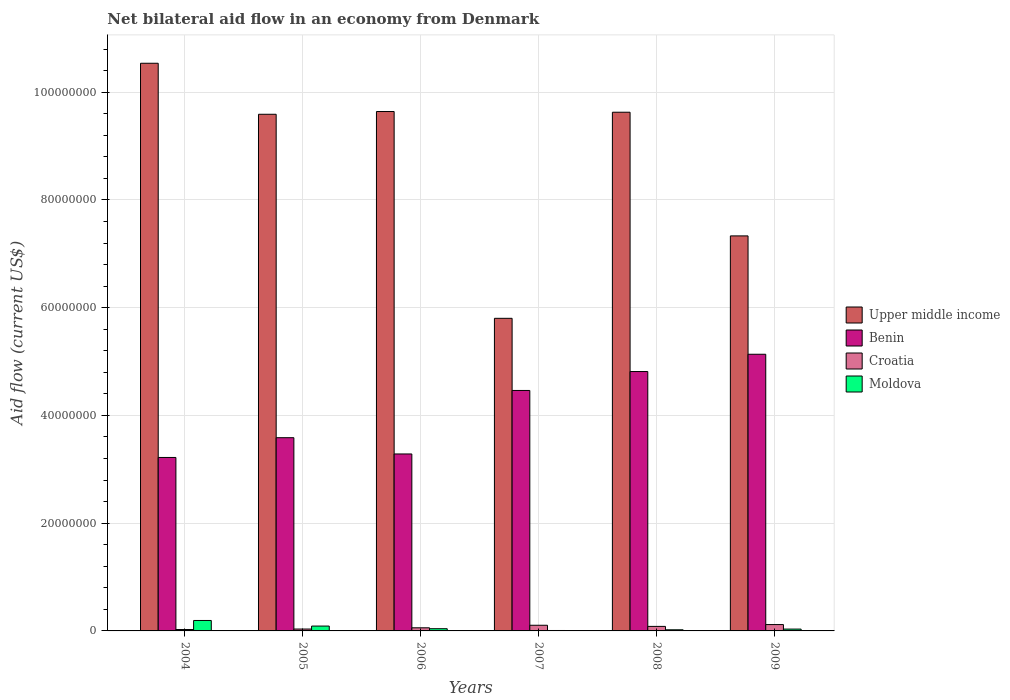How many different coloured bars are there?
Keep it short and to the point. 4. How many groups of bars are there?
Your answer should be compact. 6. How many bars are there on the 1st tick from the right?
Make the answer very short. 4. What is the label of the 2nd group of bars from the left?
Your answer should be very brief. 2005. What is the net bilateral aid flow in Upper middle income in 2009?
Provide a succinct answer. 7.33e+07. Across all years, what is the maximum net bilateral aid flow in Benin?
Offer a terse response. 5.14e+07. Across all years, what is the minimum net bilateral aid flow in Moldova?
Make the answer very short. 8.00e+04. In which year was the net bilateral aid flow in Croatia maximum?
Make the answer very short. 2009. What is the total net bilateral aid flow in Benin in the graph?
Ensure brevity in your answer.  2.45e+08. What is the difference between the net bilateral aid flow in Upper middle income in 2004 and that in 2007?
Your response must be concise. 4.74e+07. What is the difference between the net bilateral aid flow in Upper middle income in 2008 and the net bilateral aid flow in Benin in 2009?
Give a very brief answer. 4.49e+07. What is the average net bilateral aid flow in Upper middle income per year?
Make the answer very short. 8.76e+07. In the year 2008, what is the difference between the net bilateral aid flow in Croatia and net bilateral aid flow in Benin?
Offer a terse response. -4.73e+07. What is the ratio of the net bilateral aid flow in Upper middle income in 2005 to that in 2006?
Your answer should be compact. 0.99. Is the net bilateral aid flow in Croatia in 2005 less than that in 2006?
Provide a succinct answer. Yes. Is the difference between the net bilateral aid flow in Croatia in 2007 and 2008 greater than the difference between the net bilateral aid flow in Benin in 2007 and 2008?
Give a very brief answer. Yes. What is the difference between the highest and the second highest net bilateral aid flow in Moldova?
Your response must be concise. 1.04e+06. What is the difference between the highest and the lowest net bilateral aid flow in Upper middle income?
Provide a succinct answer. 4.74e+07. Is the sum of the net bilateral aid flow in Upper middle income in 2006 and 2007 greater than the maximum net bilateral aid flow in Croatia across all years?
Your answer should be very brief. Yes. Is it the case that in every year, the sum of the net bilateral aid flow in Upper middle income and net bilateral aid flow in Benin is greater than the sum of net bilateral aid flow in Croatia and net bilateral aid flow in Moldova?
Make the answer very short. Yes. What does the 3rd bar from the left in 2005 represents?
Give a very brief answer. Croatia. What does the 3rd bar from the right in 2007 represents?
Your answer should be very brief. Benin. Is it the case that in every year, the sum of the net bilateral aid flow in Croatia and net bilateral aid flow in Benin is greater than the net bilateral aid flow in Upper middle income?
Ensure brevity in your answer.  No. How many bars are there?
Ensure brevity in your answer.  24. What is the difference between two consecutive major ticks on the Y-axis?
Make the answer very short. 2.00e+07. Are the values on the major ticks of Y-axis written in scientific E-notation?
Keep it short and to the point. No. Does the graph contain any zero values?
Offer a very short reply. No. Does the graph contain grids?
Provide a short and direct response. Yes. Where does the legend appear in the graph?
Offer a very short reply. Center right. How many legend labels are there?
Your answer should be very brief. 4. How are the legend labels stacked?
Your response must be concise. Vertical. What is the title of the graph?
Your response must be concise. Net bilateral aid flow in an economy from Denmark. What is the label or title of the X-axis?
Offer a very short reply. Years. What is the label or title of the Y-axis?
Keep it short and to the point. Aid flow (current US$). What is the Aid flow (current US$) of Upper middle income in 2004?
Offer a very short reply. 1.05e+08. What is the Aid flow (current US$) of Benin in 2004?
Provide a short and direct response. 3.22e+07. What is the Aid flow (current US$) of Croatia in 2004?
Provide a short and direct response. 2.60e+05. What is the Aid flow (current US$) of Moldova in 2004?
Your answer should be compact. 1.94e+06. What is the Aid flow (current US$) of Upper middle income in 2005?
Your answer should be very brief. 9.59e+07. What is the Aid flow (current US$) in Benin in 2005?
Provide a succinct answer. 3.59e+07. What is the Aid flow (current US$) in Upper middle income in 2006?
Ensure brevity in your answer.  9.64e+07. What is the Aid flow (current US$) in Benin in 2006?
Offer a very short reply. 3.28e+07. What is the Aid flow (current US$) in Croatia in 2006?
Offer a very short reply. 5.80e+05. What is the Aid flow (current US$) of Moldova in 2006?
Give a very brief answer. 4.10e+05. What is the Aid flow (current US$) in Upper middle income in 2007?
Provide a succinct answer. 5.80e+07. What is the Aid flow (current US$) of Benin in 2007?
Ensure brevity in your answer.  4.46e+07. What is the Aid flow (current US$) in Croatia in 2007?
Give a very brief answer. 1.05e+06. What is the Aid flow (current US$) in Moldova in 2007?
Offer a very short reply. 8.00e+04. What is the Aid flow (current US$) in Upper middle income in 2008?
Your response must be concise. 9.63e+07. What is the Aid flow (current US$) in Benin in 2008?
Your answer should be compact. 4.82e+07. What is the Aid flow (current US$) in Croatia in 2008?
Provide a short and direct response. 8.40e+05. What is the Aid flow (current US$) in Moldova in 2008?
Keep it short and to the point. 2.10e+05. What is the Aid flow (current US$) in Upper middle income in 2009?
Offer a terse response. 7.33e+07. What is the Aid flow (current US$) in Benin in 2009?
Keep it short and to the point. 5.14e+07. What is the Aid flow (current US$) in Croatia in 2009?
Offer a very short reply. 1.18e+06. What is the Aid flow (current US$) in Moldova in 2009?
Give a very brief answer. 3.40e+05. Across all years, what is the maximum Aid flow (current US$) in Upper middle income?
Give a very brief answer. 1.05e+08. Across all years, what is the maximum Aid flow (current US$) of Benin?
Ensure brevity in your answer.  5.14e+07. Across all years, what is the maximum Aid flow (current US$) in Croatia?
Provide a short and direct response. 1.18e+06. Across all years, what is the maximum Aid flow (current US$) of Moldova?
Give a very brief answer. 1.94e+06. Across all years, what is the minimum Aid flow (current US$) of Upper middle income?
Your response must be concise. 5.80e+07. Across all years, what is the minimum Aid flow (current US$) of Benin?
Your response must be concise. 3.22e+07. Across all years, what is the minimum Aid flow (current US$) of Croatia?
Offer a very short reply. 2.60e+05. What is the total Aid flow (current US$) of Upper middle income in the graph?
Ensure brevity in your answer.  5.25e+08. What is the total Aid flow (current US$) in Benin in the graph?
Offer a very short reply. 2.45e+08. What is the total Aid flow (current US$) in Croatia in the graph?
Keep it short and to the point. 4.26e+06. What is the total Aid flow (current US$) of Moldova in the graph?
Make the answer very short. 3.88e+06. What is the difference between the Aid flow (current US$) in Upper middle income in 2004 and that in 2005?
Give a very brief answer. 9.47e+06. What is the difference between the Aid flow (current US$) in Benin in 2004 and that in 2005?
Provide a succinct answer. -3.67e+06. What is the difference between the Aid flow (current US$) in Moldova in 2004 and that in 2005?
Your answer should be very brief. 1.04e+06. What is the difference between the Aid flow (current US$) in Upper middle income in 2004 and that in 2006?
Provide a succinct answer. 8.96e+06. What is the difference between the Aid flow (current US$) in Benin in 2004 and that in 2006?
Your answer should be very brief. -6.50e+05. What is the difference between the Aid flow (current US$) of Croatia in 2004 and that in 2006?
Provide a succinct answer. -3.20e+05. What is the difference between the Aid flow (current US$) of Moldova in 2004 and that in 2006?
Offer a terse response. 1.53e+06. What is the difference between the Aid flow (current US$) in Upper middle income in 2004 and that in 2007?
Your response must be concise. 4.74e+07. What is the difference between the Aid flow (current US$) in Benin in 2004 and that in 2007?
Ensure brevity in your answer.  -1.24e+07. What is the difference between the Aid flow (current US$) of Croatia in 2004 and that in 2007?
Your response must be concise. -7.90e+05. What is the difference between the Aid flow (current US$) in Moldova in 2004 and that in 2007?
Offer a terse response. 1.86e+06. What is the difference between the Aid flow (current US$) in Upper middle income in 2004 and that in 2008?
Keep it short and to the point. 9.09e+06. What is the difference between the Aid flow (current US$) of Benin in 2004 and that in 2008?
Offer a very short reply. -1.60e+07. What is the difference between the Aid flow (current US$) in Croatia in 2004 and that in 2008?
Ensure brevity in your answer.  -5.80e+05. What is the difference between the Aid flow (current US$) of Moldova in 2004 and that in 2008?
Your answer should be compact. 1.73e+06. What is the difference between the Aid flow (current US$) of Upper middle income in 2004 and that in 2009?
Keep it short and to the point. 3.20e+07. What is the difference between the Aid flow (current US$) of Benin in 2004 and that in 2009?
Your answer should be compact. -1.92e+07. What is the difference between the Aid flow (current US$) of Croatia in 2004 and that in 2009?
Offer a terse response. -9.20e+05. What is the difference between the Aid flow (current US$) in Moldova in 2004 and that in 2009?
Ensure brevity in your answer.  1.60e+06. What is the difference between the Aid flow (current US$) of Upper middle income in 2005 and that in 2006?
Your answer should be compact. -5.10e+05. What is the difference between the Aid flow (current US$) in Benin in 2005 and that in 2006?
Your answer should be very brief. 3.02e+06. What is the difference between the Aid flow (current US$) of Croatia in 2005 and that in 2006?
Your answer should be very brief. -2.30e+05. What is the difference between the Aid flow (current US$) in Moldova in 2005 and that in 2006?
Your response must be concise. 4.90e+05. What is the difference between the Aid flow (current US$) in Upper middle income in 2005 and that in 2007?
Make the answer very short. 3.79e+07. What is the difference between the Aid flow (current US$) in Benin in 2005 and that in 2007?
Offer a very short reply. -8.77e+06. What is the difference between the Aid flow (current US$) in Croatia in 2005 and that in 2007?
Keep it short and to the point. -7.00e+05. What is the difference between the Aid flow (current US$) in Moldova in 2005 and that in 2007?
Provide a succinct answer. 8.20e+05. What is the difference between the Aid flow (current US$) of Upper middle income in 2005 and that in 2008?
Your answer should be very brief. -3.80e+05. What is the difference between the Aid flow (current US$) in Benin in 2005 and that in 2008?
Provide a short and direct response. -1.23e+07. What is the difference between the Aid flow (current US$) of Croatia in 2005 and that in 2008?
Your answer should be compact. -4.90e+05. What is the difference between the Aid flow (current US$) in Moldova in 2005 and that in 2008?
Keep it short and to the point. 6.90e+05. What is the difference between the Aid flow (current US$) in Upper middle income in 2005 and that in 2009?
Ensure brevity in your answer.  2.26e+07. What is the difference between the Aid flow (current US$) in Benin in 2005 and that in 2009?
Make the answer very short. -1.55e+07. What is the difference between the Aid flow (current US$) of Croatia in 2005 and that in 2009?
Give a very brief answer. -8.30e+05. What is the difference between the Aid flow (current US$) in Moldova in 2005 and that in 2009?
Your answer should be very brief. 5.60e+05. What is the difference between the Aid flow (current US$) in Upper middle income in 2006 and that in 2007?
Make the answer very short. 3.84e+07. What is the difference between the Aid flow (current US$) of Benin in 2006 and that in 2007?
Your response must be concise. -1.18e+07. What is the difference between the Aid flow (current US$) in Croatia in 2006 and that in 2007?
Give a very brief answer. -4.70e+05. What is the difference between the Aid flow (current US$) in Upper middle income in 2006 and that in 2008?
Your answer should be compact. 1.30e+05. What is the difference between the Aid flow (current US$) in Benin in 2006 and that in 2008?
Your response must be concise. -1.53e+07. What is the difference between the Aid flow (current US$) in Croatia in 2006 and that in 2008?
Offer a terse response. -2.60e+05. What is the difference between the Aid flow (current US$) of Moldova in 2006 and that in 2008?
Offer a terse response. 2.00e+05. What is the difference between the Aid flow (current US$) in Upper middle income in 2006 and that in 2009?
Keep it short and to the point. 2.31e+07. What is the difference between the Aid flow (current US$) of Benin in 2006 and that in 2009?
Your answer should be compact. -1.85e+07. What is the difference between the Aid flow (current US$) of Croatia in 2006 and that in 2009?
Provide a short and direct response. -6.00e+05. What is the difference between the Aid flow (current US$) in Moldova in 2006 and that in 2009?
Offer a very short reply. 7.00e+04. What is the difference between the Aid flow (current US$) of Upper middle income in 2007 and that in 2008?
Make the answer very short. -3.83e+07. What is the difference between the Aid flow (current US$) of Benin in 2007 and that in 2008?
Provide a short and direct response. -3.51e+06. What is the difference between the Aid flow (current US$) of Croatia in 2007 and that in 2008?
Your answer should be very brief. 2.10e+05. What is the difference between the Aid flow (current US$) of Moldova in 2007 and that in 2008?
Offer a terse response. -1.30e+05. What is the difference between the Aid flow (current US$) of Upper middle income in 2007 and that in 2009?
Your response must be concise. -1.53e+07. What is the difference between the Aid flow (current US$) in Benin in 2007 and that in 2009?
Make the answer very short. -6.72e+06. What is the difference between the Aid flow (current US$) in Moldova in 2007 and that in 2009?
Keep it short and to the point. -2.60e+05. What is the difference between the Aid flow (current US$) in Upper middle income in 2008 and that in 2009?
Keep it short and to the point. 2.30e+07. What is the difference between the Aid flow (current US$) of Benin in 2008 and that in 2009?
Offer a terse response. -3.21e+06. What is the difference between the Aid flow (current US$) in Upper middle income in 2004 and the Aid flow (current US$) in Benin in 2005?
Offer a very short reply. 6.95e+07. What is the difference between the Aid flow (current US$) of Upper middle income in 2004 and the Aid flow (current US$) of Croatia in 2005?
Keep it short and to the point. 1.05e+08. What is the difference between the Aid flow (current US$) in Upper middle income in 2004 and the Aid flow (current US$) in Moldova in 2005?
Provide a short and direct response. 1.04e+08. What is the difference between the Aid flow (current US$) of Benin in 2004 and the Aid flow (current US$) of Croatia in 2005?
Your answer should be compact. 3.18e+07. What is the difference between the Aid flow (current US$) of Benin in 2004 and the Aid flow (current US$) of Moldova in 2005?
Your response must be concise. 3.13e+07. What is the difference between the Aid flow (current US$) in Croatia in 2004 and the Aid flow (current US$) in Moldova in 2005?
Your response must be concise. -6.40e+05. What is the difference between the Aid flow (current US$) in Upper middle income in 2004 and the Aid flow (current US$) in Benin in 2006?
Give a very brief answer. 7.25e+07. What is the difference between the Aid flow (current US$) of Upper middle income in 2004 and the Aid flow (current US$) of Croatia in 2006?
Provide a succinct answer. 1.05e+08. What is the difference between the Aid flow (current US$) of Upper middle income in 2004 and the Aid flow (current US$) of Moldova in 2006?
Provide a short and direct response. 1.05e+08. What is the difference between the Aid flow (current US$) of Benin in 2004 and the Aid flow (current US$) of Croatia in 2006?
Provide a short and direct response. 3.16e+07. What is the difference between the Aid flow (current US$) of Benin in 2004 and the Aid flow (current US$) of Moldova in 2006?
Offer a very short reply. 3.18e+07. What is the difference between the Aid flow (current US$) of Upper middle income in 2004 and the Aid flow (current US$) of Benin in 2007?
Offer a very short reply. 6.07e+07. What is the difference between the Aid flow (current US$) in Upper middle income in 2004 and the Aid flow (current US$) in Croatia in 2007?
Offer a very short reply. 1.04e+08. What is the difference between the Aid flow (current US$) of Upper middle income in 2004 and the Aid flow (current US$) of Moldova in 2007?
Ensure brevity in your answer.  1.05e+08. What is the difference between the Aid flow (current US$) in Benin in 2004 and the Aid flow (current US$) in Croatia in 2007?
Provide a succinct answer. 3.12e+07. What is the difference between the Aid flow (current US$) of Benin in 2004 and the Aid flow (current US$) of Moldova in 2007?
Keep it short and to the point. 3.21e+07. What is the difference between the Aid flow (current US$) in Upper middle income in 2004 and the Aid flow (current US$) in Benin in 2008?
Your answer should be very brief. 5.72e+07. What is the difference between the Aid flow (current US$) in Upper middle income in 2004 and the Aid flow (current US$) in Croatia in 2008?
Your answer should be compact. 1.05e+08. What is the difference between the Aid flow (current US$) of Upper middle income in 2004 and the Aid flow (current US$) of Moldova in 2008?
Make the answer very short. 1.05e+08. What is the difference between the Aid flow (current US$) of Benin in 2004 and the Aid flow (current US$) of Croatia in 2008?
Offer a very short reply. 3.14e+07. What is the difference between the Aid flow (current US$) in Benin in 2004 and the Aid flow (current US$) in Moldova in 2008?
Provide a succinct answer. 3.20e+07. What is the difference between the Aid flow (current US$) of Upper middle income in 2004 and the Aid flow (current US$) of Benin in 2009?
Keep it short and to the point. 5.40e+07. What is the difference between the Aid flow (current US$) of Upper middle income in 2004 and the Aid flow (current US$) of Croatia in 2009?
Provide a short and direct response. 1.04e+08. What is the difference between the Aid flow (current US$) of Upper middle income in 2004 and the Aid flow (current US$) of Moldova in 2009?
Your answer should be very brief. 1.05e+08. What is the difference between the Aid flow (current US$) of Benin in 2004 and the Aid flow (current US$) of Croatia in 2009?
Give a very brief answer. 3.10e+07. What is the difference between the Aid flow (current US$) of Benin in 2004 and the Aid flow (current US$) of Moldova in 2009?
Your answer should be very brief. 3.19e+07. What is the difference between the Aid flow (current US$) of Upper middle income in 2005 and the Aid flow (current US$) of Benin in 2006?
Ensure brevity in your answer.  6.31e+07. What is the difference between the Aid flow (current US$) of Upper middle income in 2005 and the Aid flow (current US$) of Croatia in 2006?
Your answer should be very brief. 9.53e+07. What is the difference between the Aid flow (current US$) in Upper middle income in 2005 and the Aid flow (current US$) in Moldova in 2006?
Provide a succinct answer. 9.55e+07. What is the difference between the Aid flow (current US$) in Benin in 2005 and the Aid flow (current US$) in Croatia in 2006?
Give a very brief answer. 3.53e+07. What is the difference between the Aid flow (current US$) of Benin in 2005 and the Aid flow (current US$) of Moldova in 2006?
Offer a terse response. 3.55e+07. What is the difference between the Aid flow (current US$) of Upper middle income in 2005 and the Aid flow (current US$) of Benin in 2007?
Give a very brief answer. 5.13e+07. What is the difference between the Aid flow (current US$) of Upper middle income in 2005 and the Aid flow (current US$) of Croatia in 2007?
Your answer should be very brief. 9.49e+07. What is the difference between the Aid flow (current US$) in Upper middle income in 2005 and the Aid flow (current US$) in Moldova in 2007?
Offer a terse response. 9.58e+07. What is the difference between the Aid flow (current US$) in Benin in 2005 and the Aid flow (current US$) in Croatia in 2007?
Offer a very short reply. 3.48e+07. What is the difference between the Aid flow (current US$) of Benin in 2005 and the Aid flow (current US$) of Moldova in 2007?
Offer a terse response. 3.58e+07. What is the difference between the Aid flow (current US$) in Upper middle income in 2005 and the Aid flow (current US$) in Benin in 2008?
Your response must be concise. 4.78e+07. What is the difference between the Aid flow (current US$) of Upper middle income in 2005 and the Aid flow (current US$) of Croatia in 2008?
Offer a terse response. 9.51e+07. What is the difference between the Aid flow (current US$) of Upper middle income in 2005 and the Aid flow (current US$) of Moldova in 2008?
Make the answer very short. 9.57e+07. What is the difference between the Aid flow (current US$) of Benin in 2005 and the Aid flow (current US$) of Croatia in 2008?
Your answer should be very brief. 3.50e+07. What is the difference between the Aid flow (current US$) of Benin in 2005 and the Aid flow (current US$) of Moldova in 2008?
Give a very brief answer. 3.57e+07. What is the difference between the Aid flow (current US$) in Upper middle income in 2005 and the Aid flow (current US$) in Benin in 2009?
Provide a succinct answer. 4.46e+07. What is the difference between the Aid flow (current US$) in Upper middle income in 2005 and the Aid flow (current US$) in Croatia in 2009?
Your answer should be very brief. 9.47e+07. What is the difference between the Aid flow (current US$) in Upper middle income in 2005 and the Aid flow (current US$) in Moldova in 2009?
Give a very brief answer. 9.56e+07. What is the difference between the Aid flow (current US$) of Benin in 2005 and the Aid flow (current US$) of Croatia in 2009?
Provide a succinct answer. 3.47e+07. What is the difference between the Aid flow (current US$) of Benin in 2005 and the Aid flow (current US$) of Moldova in 2009?
Offer a terse response. 3.55e+07. What is the difference between the Aid flow (current US$) of Croatia in 2005 and the Aid flow (current US$) of Moldova in 2009?
Ensure brevity in your answer.  10000. What is the difference between the Aid flow (current US$) of Upper middle income in 2006 and the Aid flow (current US$) of Benin in 2007?
Your answer should be compact. 5.18e+07. What is the difference between the Aid flow (current US$) of Upper middle income in 2006 and the Aid flow (current US$) of Croatia in 2007?
Provide a short and direct response. 9.54e+07. What is the difference between the Aid flow (current US$) in Upper middle income in 2006 and the Aid flow (current US$) in Moldova in 2007?
Your answer should be compact. 9.63e+07. What is the difference between the Aid flow (current US$) in Benin in 2006 and the Aid flow (current US$) in Croatia in 2007?
Keep it short and to the point. 3.18e+07. What is the difference between the Aid flow (current US$) in Benin in 2006 and the Aid flow (current US$) in Moldova in 2007?
Offer a terse response. 3.28e+07. What is the difference between the Aid flow (current US$) in Croatia in 2006 and the Aid flow (current US$) in Moldova in 2007?
Ensure brevity in your answer.  5.00e+05. What is the difference between the Aid flow (current US$) of Upper middle income in 2006 and the Aid flow (current US$) of Benin in 2008?
Give a very brief answer. 4.83e+07. What is the difference between the Aid flow (current US$) of Upper middle income in 2006 and the Aid flow (current US$) of Croatia in 2008?
Provide a short and direct response. 9.56e+07. What is the difference between the Aid flow (current US$) of Upper middle income in 2006 and the Aid flow (current US$) of Moldova in 2008?
Your answer should be compact. 9.62e+07. What is the difference between the Aid flow (current US$) of Benin in 2006 and the Aid flow (current US$) of Croatia in 2008?
Keep it short and to the point. 3.20e+07. What is the difference between the Aid flow (current US$) of Benin in 2006 and the Aid flow (current US$) of Moldova in 2008?
Offer a very short reply. 3.26e+07. What is the difference between the Aid flow (current US$) of Upper middle income in 2006 and the Aid flow (current US$) of Benin in 2009?
Your answer should be very brief. 4.51e+07. What is the difference between the Aid flow (current US$) of Upper middle income in 2006 and the Aid flow (current US$) of Croatia in 2009?
Make the answer very short. 9.52e+07. What is the difference between the Aid flow (current US$) of Upper middle income in 2006 and the Aid flow (current US$) of Moldova in 2009?
Offer a terse response. 9.61e+07. What is the difference between the Aid flow (current US$) in Benin in 2006 and the Aid flow (current US$) in Croatia in 2009?
Your answer should be very brief. 3.17e+07. What is the difference between the Aid flow (current US$) of Benin in 2006 and the Aid flow (current US$) of Moldova in 2009?
Make the answer very short. 3.25e+07. What is the difference between the Aid flow (current US$) in Croatia in 2006 and the Aid flow (current US$) in Moldova in 2009?
Ensure brevity in your answer.  2.40e+05. What is the difference between the Aid flow (current US$) in Upper middle income in 2007 and the Aid flow (current US$) in Benin in 2008?
Make the answer very short. 9.88e+06. What is the difference between the Aid flow (current US$) of Upper middle income in 2007 and the Aid flow (current US$) of Croatia in 2008?
Offer a terse response. 5.72e+07. What is the difference between the Aid flow (current US$) of Upper middle income in 2007 and the Aid flow (current US$) of Moldova in 2008?
Offer a terse response. 5.78e+07. What is the difference between the Aid flow (current US$) in Benin in 2007 and the Aid flow (current US$) in Croatia in 2008?
Make the answer very short. 4.38e+07. What is the difference between the Aid flow (current US$) of Benin in 2007 and the Aid flow (current US$) of Moldova in 2008?
Give a very brief answer. 4.44e+07. What is the difference between the Aid flow (current US$) of Croatia in 2007 and the Aid flow (current US$) of Moldova in 2008?
Ensure brevity in your answer.  8.40e+05. What is the difference between the Aid flow (current US$) in Upper middle income in 2007 and the Aid flow (current US$) in Benin in 2009?
Offer a very short reply. 6.67e+06. What is the difference between the Aid flow (current US$) of Upper middle income in 2007 and the Aid flow (current US$) of Croatia in 2009?
Your answer should be very brief. 5.68e+07. What is the difference between the Aid flow (current US$) in Upper middle income in 2007 and the Aid flow (current US$) in Moldova in 2009?
Your answer should be compact. 5.77e+07. What is the difference between the Aid flow (current US$) in Benin in 2007 and the Aid flow (current US$) in Croatia in 2009?
Offer a very short reply. 4.35e+07. What is the difference between the Aid flow (current US$) in Benin in 2007 and the Aid flow (current US$) in Moldova in 2009?
Offer a very short reply. 4.43e+07. What is the difference between the Aid flow (current US$) of Croatia in 2007 and the Aid flow (current US$) of Moldova in 2009?
Provide a succinct answer. 7.10e+05. What is the difference between the Aid flow (current US$) in Upper middle income in 2008 and the Aid flow (current US$) in Benin in 2009?
Make the answer very short. 4.49e+07. What is the difference between the Aid flow (current US$) of Upper middle income in 2008 and the Aid flow (current US$) of Croatia in 2009?
Offer a very short reply. 9.51e+07. What is the difference between the Aid flow (current US$) in Upper middle income in 2008 and the Aid flow (current US$) in Moldova in 2009?
Keep it short and to the point. 9.60e+07. What is the difference between the Aid flow (current US$) in Benin in 2008 and the Aid flow (current US$) in Croatia in 2009?
Make the answer very short. 4.70e+07. What is the difference between the Aid flow (current US$) of Benin in 2008 and the Aid flow (current US$) of Moldova in 2009?
Make the answer very short. 4.78e+07. What is the difference between the Aid flow (current US$) in Croatia in 2008 and the Aid flow (current US$) in Moldova in 2009?
Your answer should be compact. 5.00e+05. What is the average Aid flow (current US$) in Upper middle income per year?
Offer a terse response. 8.76e+07. What is the average Aid flow (current US$) of Benin per year?
Give a very brief answer. 4.08e+07. What is the average Aid flow (current US$) in Croatia per year?
Give a very brief answer. 7.10e+05. What is the average Aid flow (current US$) of Moldova per year?
Your response must be concise. 6.47e+05. In the year 2004, what is the difference between the Aid flow (current US$) of Upper middle income and Aid flow (current US$) of Benin?
Give a very brief answer. 7.32e+07. In the year 2004, what is the difference between the Aid flow (current US$) in Upper middle income and Aid flow (current US$) in Croatia?
Your response must be concise. 1.05e+08. In the year 2004, what is the difference between the Aid flow (current US$) in Upper middle income and Aid flow (current US$) in Moldova?
Provide a short and direct response. 1.03e+08. In the year 2004, what is the difference between the Aid flow (current US$) of Benin and Aid flow (current US$) of Croatia?
Your answer should be compact. 3.19e+07. In the year 2004, what is the difference between the Aid flow (current US$) of Benin and Aid flow (current US$) of Moldova?
Make the answer very short. 3.03e+07. In the year 2004, what is the difference between the Aid flow (current US$) of Croatia and Aid flow (current US$) of Moldova?
Make the answer very short. -1.68e+06. In the year 2005, what is the difference between the Aid flow (current US$) in Upper middle income and Aid flow (current US$) in Benin?
Give a very brief answer. 6.00e+07. In the year 2005, what is the difference between the Aid flow (current US$) of Upper middle income and Aid flow (current US$) of Croatia?
Make the answer very short. 9.56e+07. In the year 2005, what is the difference between the Aid flow (current US$) in Upper middle income and Aid flow (current US$) in Moldova?
Provide a short and direct response. 9.50e+07. In the year 2005, what is the difference between the Aid flow (current US$) in Benin and Aid flow (current US$) in Croatia?
Your answer should be very brief. 3.55e+07. In the year 2005, what is the difference between the Aid flow (current US$) of Benin and Aid flow (current US$) of Moldova?
Give a very brief answer. 3.50e+07. In the year 2005, what is the difference between the Aid flow (current US$) of Croatia and Aid flow (current US$) of Moldova?
Offer a terse response. -5.50e+05. In the year 2006, what is the difference between the Aid flow (current US$) of Upper middle income and Aid flow (current US$) of Benin?
Provide a short and direct response. 6.36e+07. In the year 2006, what is the difference between the Aid flow (current US$) of Upper middle income and Aid flow (current US$) of Croatia?
Offer a very short reply. 9.58e+07. In the year 2006, what is the difference between the Aid flow (current US$) in Upper middle income and Aid flow (current US$) in Moldova?
Ensure brevity in your answer.  9.60e+07. In the year 2006, what is the difference between the Aid flow (current US$) in Benin and Aid flow (current US$) in Croatia?
Offer a very short reply. 3.23e+07. In the year 2006, what is the difference between the Aid flow (current US$) in Benin and Aid flow (current US$) in Moldova?
Keep it short and to the point. 3.24e+07. In the year 2007, what is the difference between the Aid flow (current US$) in Upper middle income and Aid flow (current US$) in Benin?
Your response must be concise. 1.34e+07. In the year 2007, what is the difference between the Aid flow (current US$) in Upper middle income and Aid flow (current US$) in Croatia?
Offer a terse response. 5.70e+07. In the year 2007, what is the difference between the Aid flow (current US$) of Upper middle income and Aid flow (current US$) of Moldova?
Give a very brief answer. 5.80e+07. In the year 2007, what is the difference between the Aid flow (current US$) of Benin and Aid flow (current US$) of Croatia?
Your answer should be very brief. 4.36e+07. In the year 2007, what is the difference between the Aid flow (current US$) in Benin and Aid flow (current US$) in Moldova?
Offer a very short reply. 4.46e+07. In the year 2007, what is the difference between the Aid flow (current US$) in Croatia and Aid flow (current US$) in Moldova?
Give a very brief answer. 9.70e+05. In the year 2008, what is the difference between the Aid flow (current US$) in Upper middle income and Aid flow (current US$) in Benin?
Offer a very short reply. 4.81e+07. In the year 2008, what is the difference between the Aid flow (current US$) of Upper middle income and Aid flow (current US$) of Croatia?
Provide a short and direct response. 9.54e+07. In the year 2008, what is the difference between the Aid flow (current US$) of Upper middle income and Aid flow (current US$) of Moldova?
Offer a terse response. 9.61e+07. In the year 2008, what is the difference between the Aid flow (current US$) in Benin and Aid flow (current US$) in Croatia?
Ensure brevity in your answer.  4.73e+07. In the year 2008, what is the difference between the Aid flow (current US$) in Benin and Aid flow (current US$) in Moldova?
Your answer should be compact. 4.79e+07. In the year 2008, what is the difference between the Aid flow (current US$) in Croatia and Aid flow (current US$) in Moldova?
Provide a short and direct response. 6.30e+05. In the year 2009, what is the difference between the Aid flow (current US$) in Upper middle income and Aid flow (current US$) in Benin?
Your response must be concise. 2.20e+07. In the year 2009, what is the difference between the Aid flow (current US$) of Upper middle income and Aid flow (current US$) of Croatia?
Offer a very short reply. 7.22e+07. In the year 2009, what is the difference between the Aid flow (current US$) in Upper middle income and Aid flow (current US$) in Moldova?
Provide a short and direct response. 7.30e+07. In the year 2009, what is the difference between the Aid flow (current US$) of Benin and Aid flow (current US$) of Croatia?
Ensure brevity in your answer.  5.02e+07. In the year 2009, what is the difference between the Aid flow (current US$) of Benin and Aid flow (current US$) of Moldova?
Your answer should be very brief. 5.10e+07. In the year 2009, what is the difference between the Aid flow (current US$) of Croatia and Aid flow (current US$) of Moldova?
Offer a terse response. 8.40e+05. What is the ratio of the Aid flow (current US$) in Upper middle income in 2004 to that in 2005?
Provide a short and direct response. 1.1. What is the ratio of the Aid flow (current US$) of Benin in 2004 to that in 2005?
Ensure brevity in your answer.  0.9. What is the ratio of the Aid flow (current US$) in Croatia in 2004 to that in 2005?
Make the answer very short. 0.74. What is the ratio of the Aid flow (current US$) in Moldova in 2004 to that in 2005?
Provide a succinct answer. 2.16. What is the ratio of the Aid flow (current US$) of Upper middle income in 2004 to that in 2006?
Make the answer very short. 1.09. What is the ratio of the Aid flow (current US$) of Benin in 2004 to that in 2006?
Make the answer very short. 0.98. What is the ratio of the Aid flow (current US$) of Croatia in 2004 to that in 2006?
Your response must be concise. 0.45. What is the ratio of the Aid flow (current US$) in Moldova in 2004 to that in 2006?
Offer a terse response. 4.73. What is the ratio of the Aid flow (current US$) of Upper middle income in 2004 to that in 2007?
Your answer should be compact. 1.82. What is the ratio of the Aid flow (current US$) in Benin in 2004 to that in 2007?
Offer a terse response. 0.72. What is the ratio of the Aid flow (current US$) in Croatia in 2004 to that in 2007?
Your answer should be compact. 0.25. What is the ratio of the Aid flow (current US$) of Moldova in 2004 to that in 2007?
Your answer should be very brief. 24.25. What is the ratio of the Aid flow (current US$) of Upper middle income in 2004 to that in 2008?
Your response must be concise. 1.09. What is the ratio of the Aid flow (current US$) in Benin in 2004 to that in 2008?
Your response must be concise. 0.67. What is the ratio of the Aid flow (current US$) in Croatia in 2004 to that in 2008?
Keep it short and to the point. 0.31. What is the ratio of the Aid flow (current US$) of Moldova in 2004 to that in 2008?
Offer a very short reply. 9.24. What is the ratio of the Aid flow (current US$) of Upper middle income in 2004 to that in 2009?
Offer a very short reply. 1.44. What is the ratio of the Aid flow (current US$) of Benin in 2004 to that in 2009?
Keep it short and to the point. 0.63. What is the ratio of the Aid flow (current US$) in Croatia in 2004 to that in 2009?
Your response must be concise. 0.22. What is the ratio of the Aid flow (current US$) in Moldova in 2004 to that in 2009?
Provide a short and direct response. 5.71. What is the ratio of the Aid flow (current US$) in Upper middle income in 2005 to that in 2006?
Your answer should be very brief. 0.99. What is the ratio of the Aid flow (current US$) of Benin in 2005 to that in 2006?
Provide a short and direct response. 1.09. What is the ratio of the Aid flow (current US$) in Croatia in 2005 to that in 2006?
Ensure brevity in your answer.  0.6. What is the ratio of the Aid flow (current US$) in Moldova in 2005 to that in 2006?
Give a very brief answer. 2.2. What is the ratio of the Aid flow (current US$) in Upper middle income in 2005 to that in 2007?
Give a very brief answer. 1.65. What is the ratio of the Aid flow (current US$) of Benin in 2005 to that in 2007?
Ensure brevity in your answer.  0.8. What is the ratio of the Aid flow (current US$) in Moldova in 2005 to that in 2007?
Offer a terse response. 11.25. What is the ratio of the Aid flow (current US$) of Upper middle income in 2005 to that in 2008?
Offer a terse response. 1. What is the ratio of the Aid flow (current US$) in Benin in 2005 to that in 2008?
Offer a terse response. 0.74. What is the ratio of the Aid flow (current US$) of Croatia in 2005 to that in 2008?
Provide a succinct answer. 0.42. What is the ratio of the Aid flow (current US$) in Moldova in 2005 to that in 2008?
Provide a short and direct response. 4.29. What is the ratio of the Aid flow (current US$) of Upper middle income in 2005 to that in 2009?
Your answer should be very brief. 1.31. What is the ratio of the Aid flow (current US$) of Benin in 2005 to that in 2009?
Keep it short and to the point. 0.7. What is the ratio of the Aid flow (current US$) of Croatia in 2005 to that in 2009?
Your answer should be very brief. 0.3. What is the ratio of the Aid flow (current US$) of Moldova in 2005 to that in 2009?
Your answer should be compact. 2.65. What is the ratio of the Aid flow (current US$) in Upper middle income in 2006 to that in 2007?
Your answer should be very brief. 1.66. What is the ratio of the Aid flow (current US$) in Benin in 2006 to that in 2007?
Provide a succinct answer. 0.74. What is the ratio of the Aid flow (current US$) in Croatia in 2006 to that in 2007?
Make the answer very short. 0.55. What is the ratio of the Aid flow (current US$) in Moldova in 2006 to that in 2007?
Provide a short and direct response. 5.12. What is the ratio of the Aid flow (current US$) in Upper middle income in 2006 to that in 2008?
Ensure brevity in your answer.  1. What is the ratio of the Aid flow (current US$) in Benin in 2006 to that in 2008?
Your response must be concise. 0.68. What is the ratio of the Aid flow (current US$) of Croatia in 2006 to that in 2008?
Provide a short and direct response. 0.69. What is the ratio of the Aid flow (current US$) of Moldova in 2006 to that in 2008?
Your response must be concise. 1.95. What is the ratio of the Aid flow (current US$) of Upper middle income in 2006 to that in 2009?
Give a very brief answer. 1.31. What is the ratio of the Aid flow (current US$) in Benin in 2006 to that in 2009?
Offer a terse response. 0.64. What is the ratio of the Aid flow (current US$) of Croatia in 2006 to that in 2009?
Provide a succinct answer. 0.49. What is the ratio of the Aid flow (current US$) of Moldova in 2006 to that in 2009?
Offer a terse response. 1.21. What is the ratio of the Aid flow (current US$) of Upper middle income in 2007 to that in 2008?
Your answer should be compact. 0.6. What is the ratio of the Aid flow (current US$) in Benin in 2007 to that in 2008?
Your response must be concise. 0.93. What is the ratio of the Aid flow (current US$) of Moldova in 2007 to that in 2008?
Your answer should be compact. 0.38. What is the ratio of the Aid flow (current US$) in Upper middle income in 2007 to that in 2009?
Your answer should be compact. 0.79. What is the ratio of the Aid flow (current US$) in Benin in 2007 to that in 2009?
Make the answer very short. 0.87. What is the ratio of the Aid flow (current US$) in Croatia in 2007 to that in 2009?
Your response must be concise. 0.89. What is the ratio of the Aid flow (current US$) of Moldova in 2007 to that in 2009?
Give a very brief answer. 0.24. What is the ratio of the Aid flow (current US$) of Upper middle income in 2008 to that in 2009?
Keep it short and to the point. 1.31. What is the ratio of the Aid flow (current US$) of Croatia in 2008 to that in 2009?
Ensure brevity in your answer.  0.71. What is the ratio of the Aid flow (current US$) of Moldova in 2008 to that in 2009?
Provide a short and direct response. 0.62. What is the difference between the highest and the second highest Aid flow (current US$) of Upper middle income?
Your answer should be very brief. 8.96e+06. What is the difference between the highest and the second highest Aid flow (current US$) in Benin?
Provide a succinct answer. 3.21e+06. What is the difference between the highest and the second highest Aid flow (current US$) in Croatia?
Keep it short and to the point. 1.30e+05. What is the difference between the highest and the second highest Aid flow (current US$) of Moldova?
Offer a very short reply. 1.04e+06. What is the difference between the highest and the lowest Aid flow (current US$) in Upper middle income?
Ensure brevity in your answer.  4.74e+07. What is the difference between the highest and the lowest Aid flow (current US$) in Benin?
Offer a very short reply. 1.92e+07. What is the difference between the highest and the lowest Aid flow (current US$) of Croatia?
Make the answer very short. 9.20e+05. What is the difference between the highest and the lowest Aid flow (current US$) in Moldova?
Keep it short and to the point. 1.86e+06. 